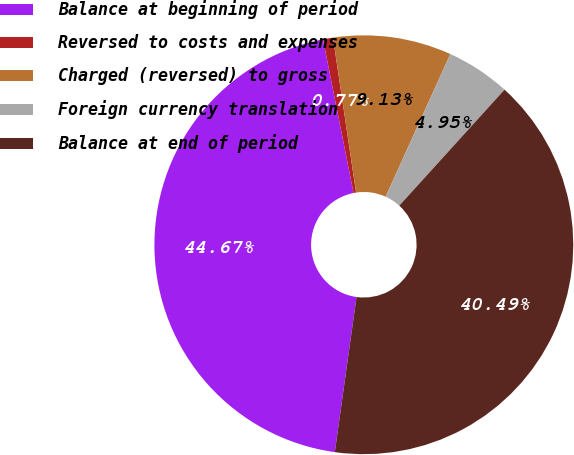Convert chart to OTSL. <chart><loc_0><loc_0><loc_500><loc_500><pie_chart><fcel>Balance at beginning of period<fcel>Reversed to costs and expenses<fcel>Charged (reversed) to gross<fcel>Foreign currency translation<fcel>Balance at end of period<nl><fcel>44.67%<fcel>0.77%<fcel>9.13%<fcel>4.95%<fcel>40.49%<nl></chart> 